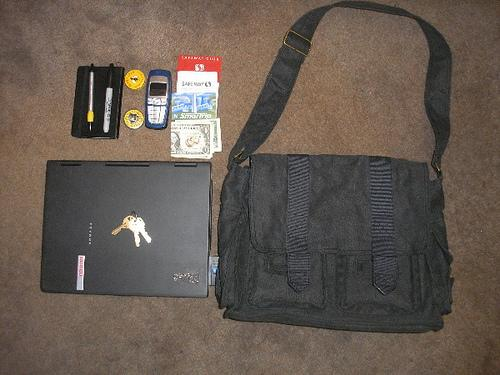What is on the laptop? Please explain your reasoning. keys. The things on the laptop are made of metal and joined on a ring. 